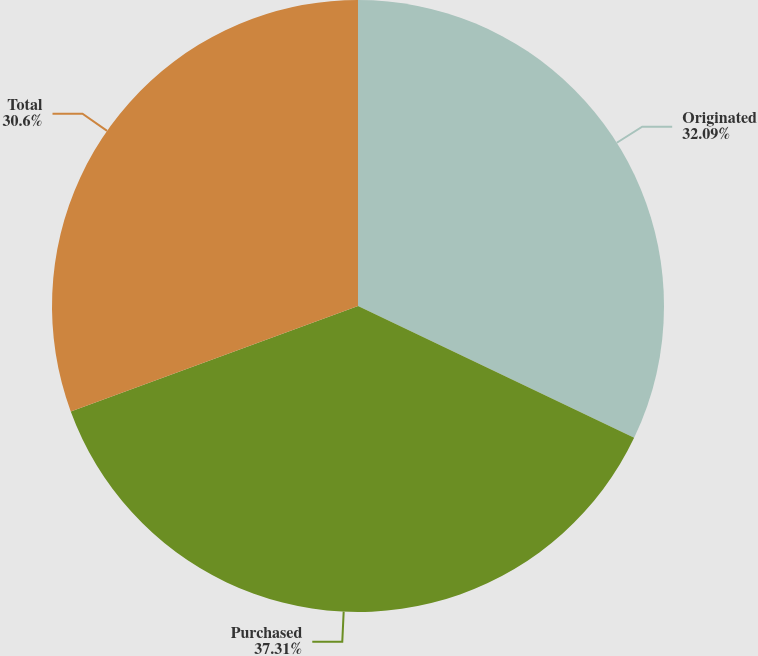Convert chart. <chart><loc_0><loc_0><loc_500><loc_500><pie_chart><fcel>Originated<fcel>Purchased<fcel>Total<nl><fcel>32.09%<fcel>37.31%<fcel>30.6%<nl></chart> 